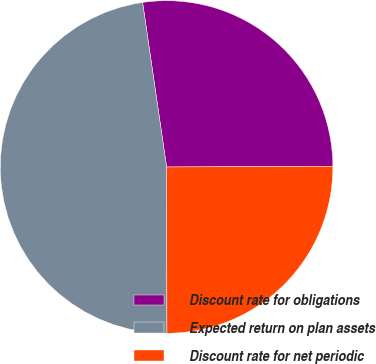<chart> <loc_0><loc_0><loc_500><loc_500><pie_chart><fcel>Discount rate for obligations<fcel>Expected return on plan assets<fcel>Discount rate for net periodic<nl><fcel>27.25%<fcel>47.73%<fcel>25.02%<nl></chart> 